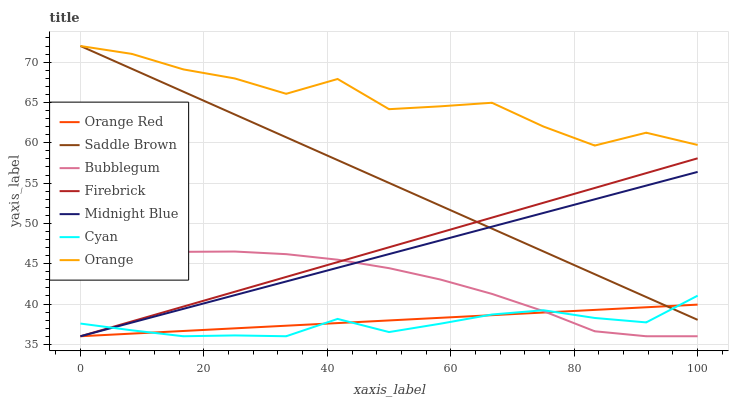Does Cyan have the minimum area under the curve?
Answer yes or no. Yes. Does Orange have the maximum area under the curve?
Answer yes or no. Yes. Does Firebrick have the minimum area under the curve?
Answer yes or no. No. Does Firebrick have the maximum area under the curve?
Answer yes or no. No. Is Saddle Brown the smoothest?
Answer yes or no. Yes. Is Orange the roughest?
Answer yes or no. Yes. Is Firebrick the smoothest?
Answer yes or no. No. Is Firebrick the roughest?
Answer yes or no. No. Does Midnight Blue have the lowest value?
Answer yes or no. Yes. Does Saddle Brown have the lowest value?
Answer yes or no. No. Does Orange have the highest value?
Answer yes or no. Yes. Does Firebrick have the highest value?
Answer yes or no. No. Is Bubblegum less than Saddle Brown?
Answer yes or no. Yes. Is Orange greater than Orange Red?
Answer yes or no. Yes. Does Firebrick intersect Saddle Brown?
Answer yes or no. Yes. Is Firebrick less than Saddle Brown?
Answer yes or no. No. Is Firebrick greater than Saddle Brown?
Answer yes or no. No. Does Bubblegum intersect Saddle Brown?
Answer yes or no. No. 